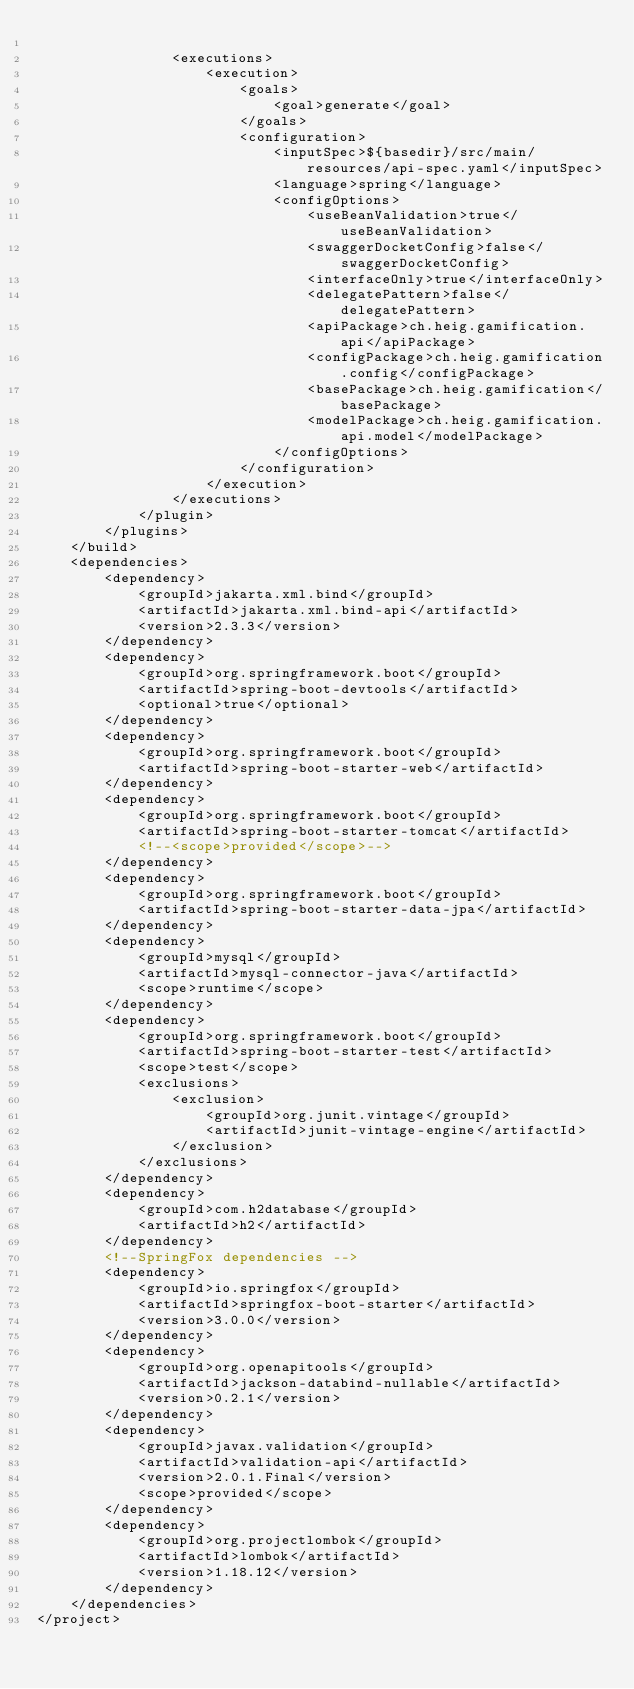<code> <loc_0><loc_0><loc_500><loc_500><_XML_>
                <executions>
                    <execution>
                        <goals>
                            <goal>generate</goal>
                        </goals>
                        <configuration>
                            <inputSpec>${basedir}/src/main/resources/api-spec.yaml</inputSpec>
                            <language>spring</language>
                            <configOptions>
                                <useBeanValidation>true</useBeanValidation>
                                <swaggerDocketConfig>false</swaggerDocketConfig>
                                <interfaceOnly>true</interfaceOnly>
                                <delegatePattern>false</delegatePattern>
                                <apiPackage>ch.heig.gamification.api</apiPackage>
                                <configPackage>ch.heig.gamification.config</configPackage>
                                <basePackage>ch.heig.gamification</basePackage>
                                <modelPackage>ch.heig.gamification.api.model</modelPackage>
                            </configOptions>
                        </configuration>
                    </execution>
                </executions>
            </plugin>
        </plugins>
    </build>
    <dependencies>
        <dependency>
            <groupId>jakarta.xml.bind</groupId>
            <artifactId>jakarta.xml.bind-api</artifactId>
            <version>2.3.3</version>
        </dependency>
        <dependency>
            <groupId>org.springframework.boot</groupId>
            <artifactId>spring-boot-devtools</artifactId>
            <optional>true</optional>
        </dependency>
        <dependency>
            <groupId>org.springframework.boot</groupId>
            <artifactId>spring-boot-starter-web</artifactId>
        </dependency>
        <dependency>
            <groupId>org.springframework.boot</groupId>
            <artifactId>spring-boot-starter-tomcat</artifactId>
            <!--<scope>provided</scope>-->
        </dependency>
        <dependency>
            <groupId>org.springframework.boot</groupId>
            <artifactId>spring-boot-starter-data-jpa</artifactId>
        </dependency>
        <dependency>
            <groupId>mysql</groupId>
            <artifactId>mysql-connector-java</artifactId>
            <scope>runtime</scope>
        </dependency>
        <dependency>
            <groupId>org.springframework.boot</groupId>
            <artifactId>spring-boot-starter-test</artifactId>
            <scope>test</scope>
            <exclusions>
                <exclusion>
                    <groupId>org.junit.vintage</groupId>
                    <artifactId>junit-vintage-engine</artifactId>
                </exclusion>
            </exclusions>
        </dependency>
        <dependency>
            <groupId>com.h2database</groupId>
            <artifactId>h2</artifactId>
        </dependency>
        <!--SpringFox dependencies -->
        <dependency>
            <groupId>io.springfox</groupId>
            <artifactId>springfox-boot-starter</artifactId>
            <version>3.0.0</version>
        </dependency>
        <dependency>
            <groupId>org.openapitools</groupId>
            <artifactId>jackson-databind-nullable</artifactId>
            <version>0.2.1</version>
        </dependency>
        <dependency>
            <groupId>javax.validation</groupId>
            <artifactId>validation-api</artifactId>
            <version>2.0.1.Final</version>
            <scope>provided</scope>
        </dependency>
        <dependency>
            <groupId>org.projectlombok</groupId>
            <artifactId>lombok</artifactId>
            <version>1.18.12</version>
        </dependency>
    </dependencies>
</project>
</code> 